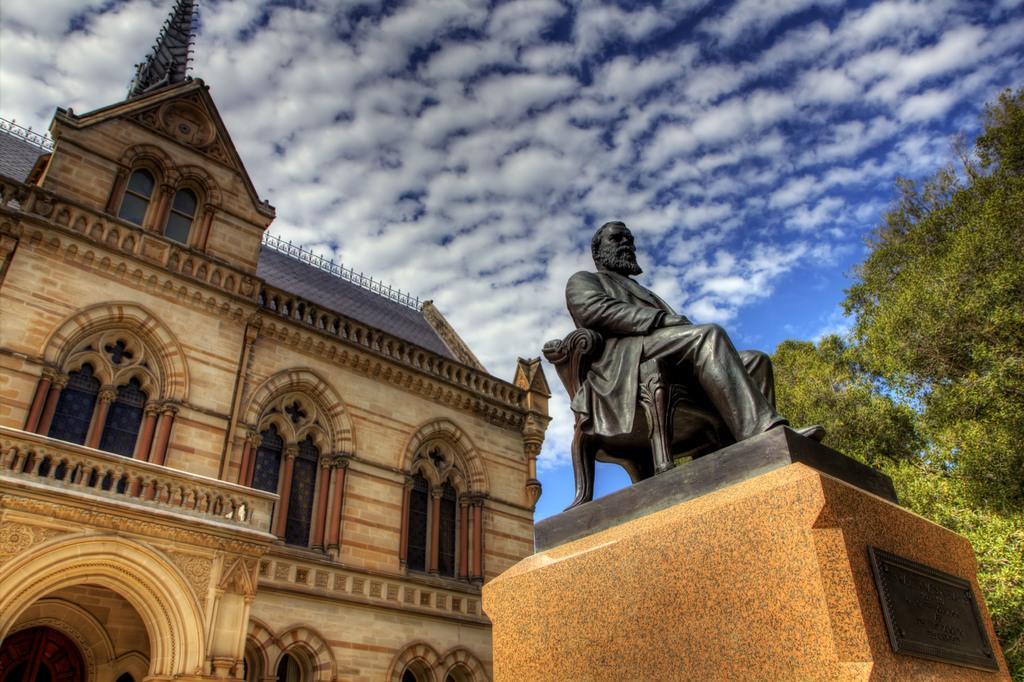Describe this image in one or two sentences. There is a building and in front of the building there is sculpture of a person, it is of black color and beside the sculpture there is a tree and in the background there is a sky. 